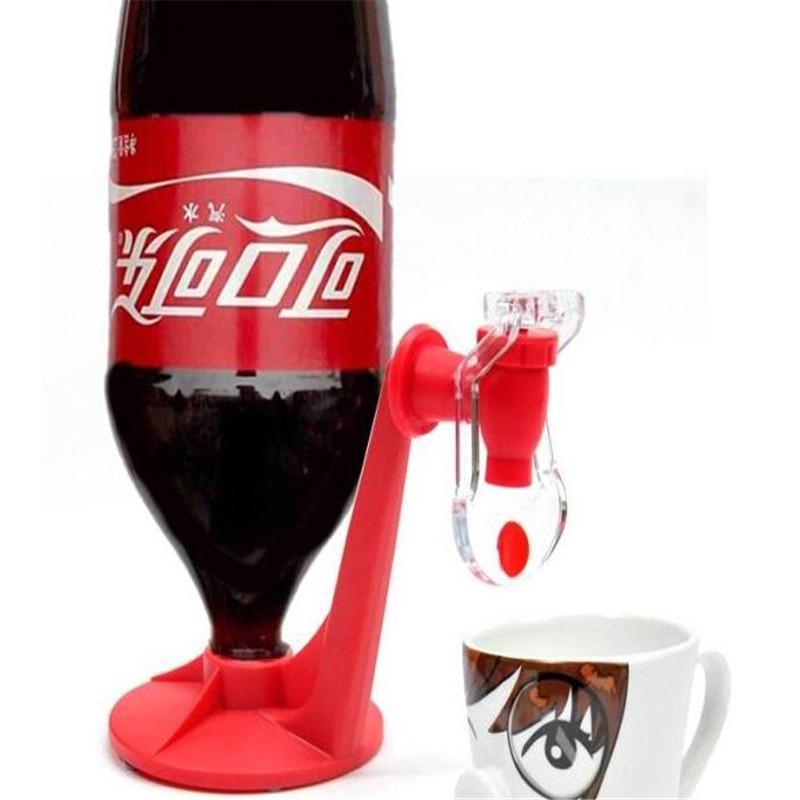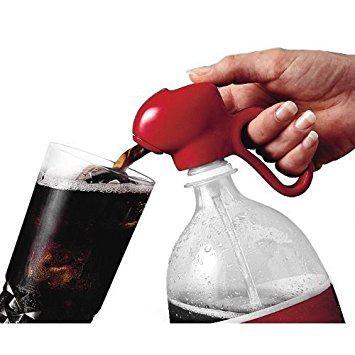The first image is the image on the left, the second image is the image on the right. Analyze the images presented: Is the assertion "One of the soda bottles is green." valid? Answer yes or no. No. The first image is the image on the left, the second image is the image on the right. Considering the images on both sides, is "In at least one image there is a upside coke bottle labeled in a different language sitting on a red tap." valid? Answer yes or no. Yes. 